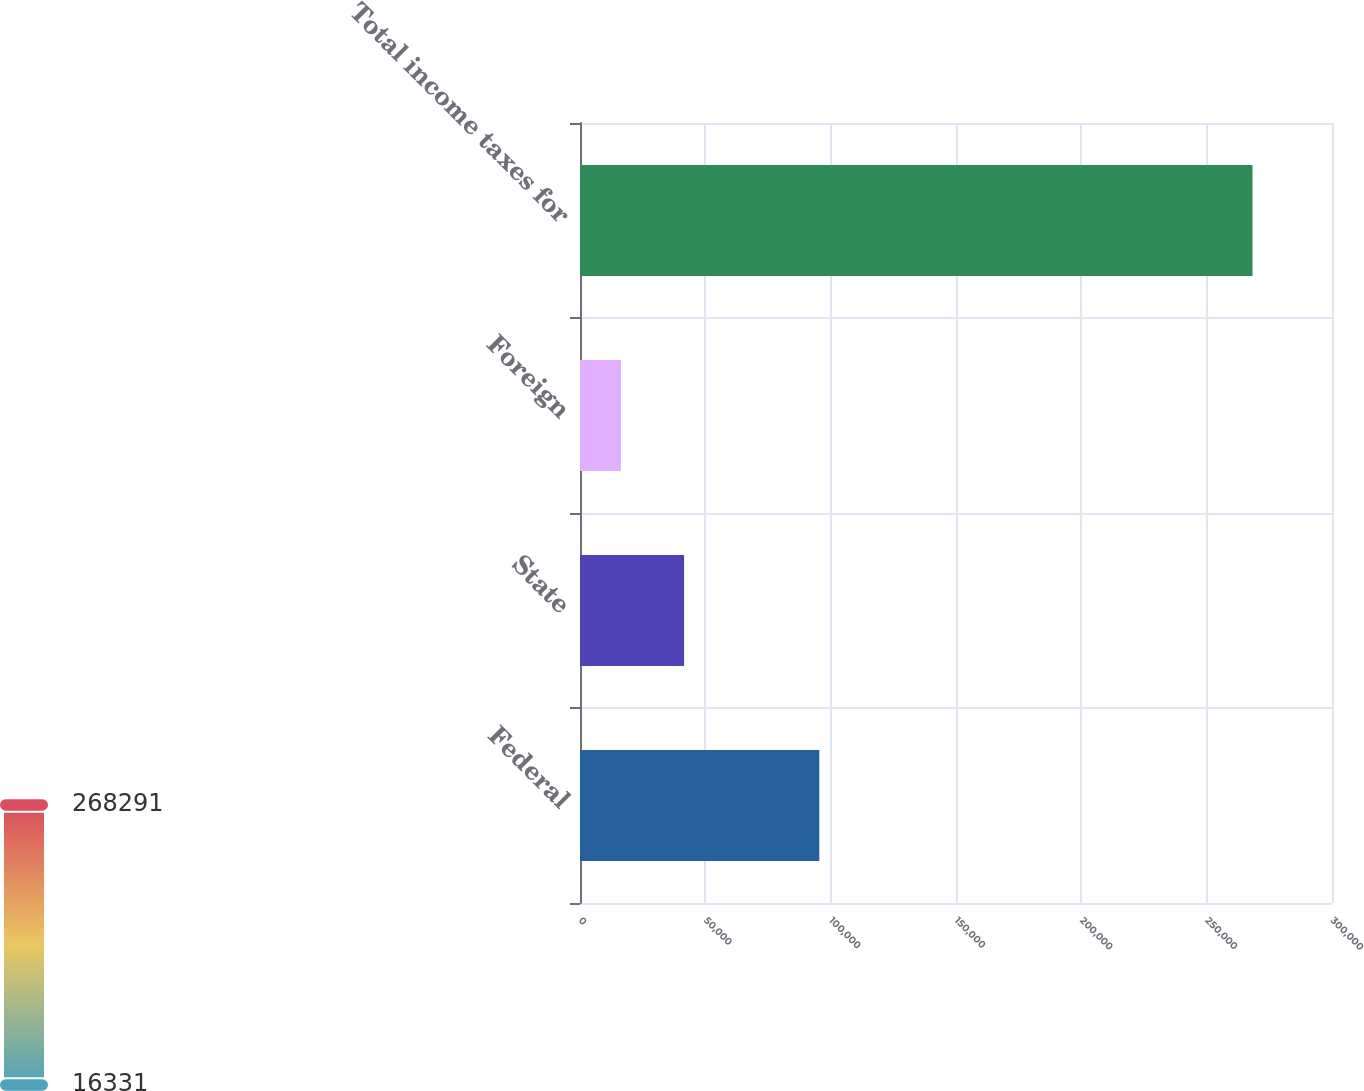Convert chart to OTSL. <chart><loc_0><loc_0><loc_500><loc_500><bar_chart><fcel>Federal<fcel>State<fcel>Foreign<fcel>Total income taxes for<nl><fcel>95473<fcel>41527<fcel>16331<fcel>268291<nl></chart> 